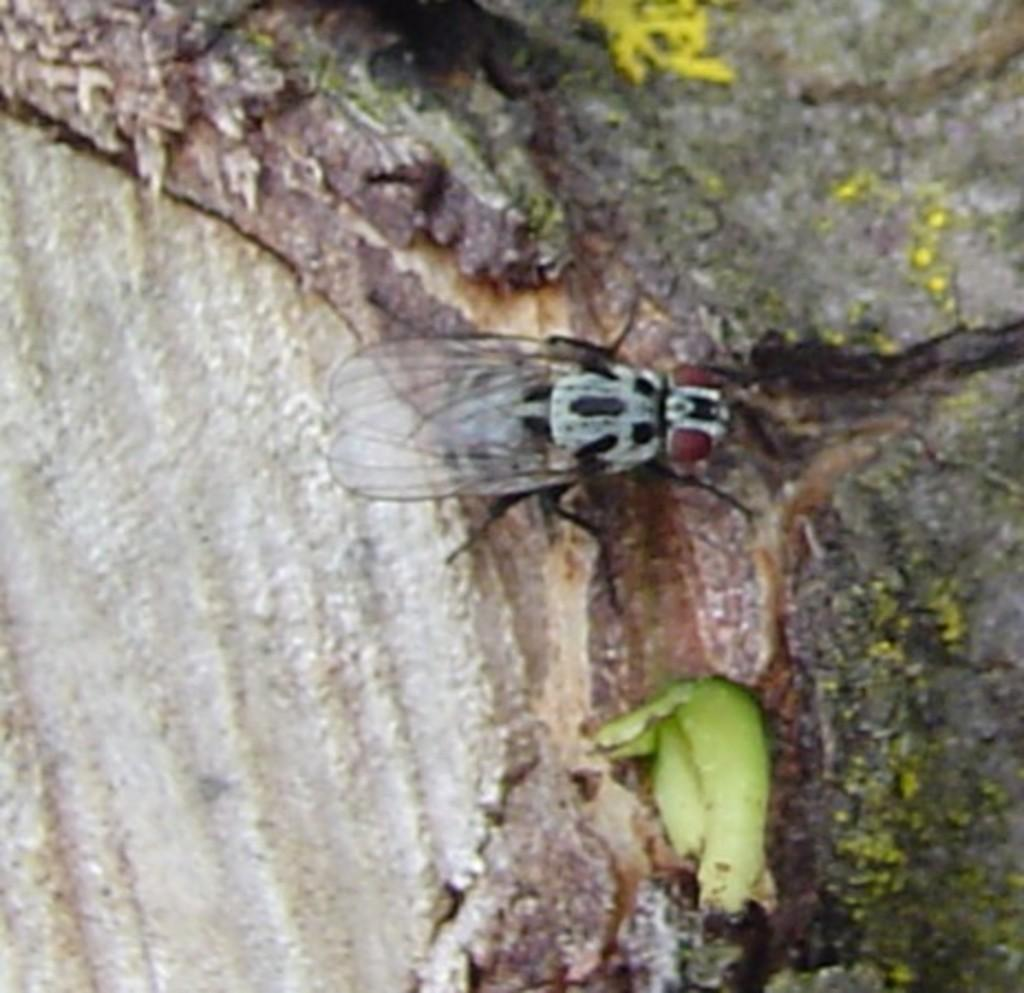What is the main subject of the image? There is a housefly in the center of the image. Can you describe the setting of the image? There is a walkway in the background of the image. What invention can be seen in the image? There is no invention present in the image; it features a housefly and a walkway. What type of zebra is visible in the image? There is no zebra present in the image. 